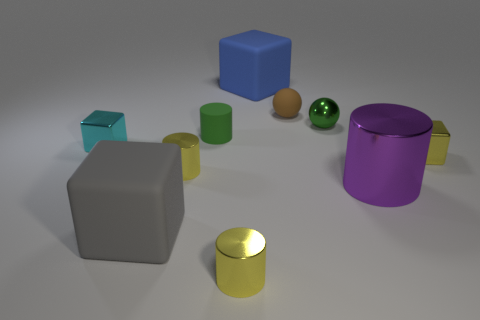Is the number of things that are left of the small cyan metal block less than the number of big blue cubes?
Ensure brevity in your answer.  Yes. Are any small purple metal cubes visible?
Your answer should be very brief. No. Are there fewer small spheres than big gray matte objects?
Offer a very short reply. No. How many red things have the same material as the brown object?
Provide a short and direct response. 0. There is a tiny cylinder that is made of the same material as the large blue block; what is its color?
Offer a terse response. Green. There is a large purple object; what shape is it?
Provide a succinct answer. Cylinder. How many rubber cubes are the same color as the large cylinder?
Provide a short and direct response. 0. What is the shape of the gray thing that is the same size as the purple shiny cylinder?
Keep it short and to the point. Cube. Is there a gray thing that has the same size as the blue block?
Your answer should be very brief. Yes. There is a cylinder that is the same size as the gray cube; what is it made of?
Provide a short and direct response. Metal. 